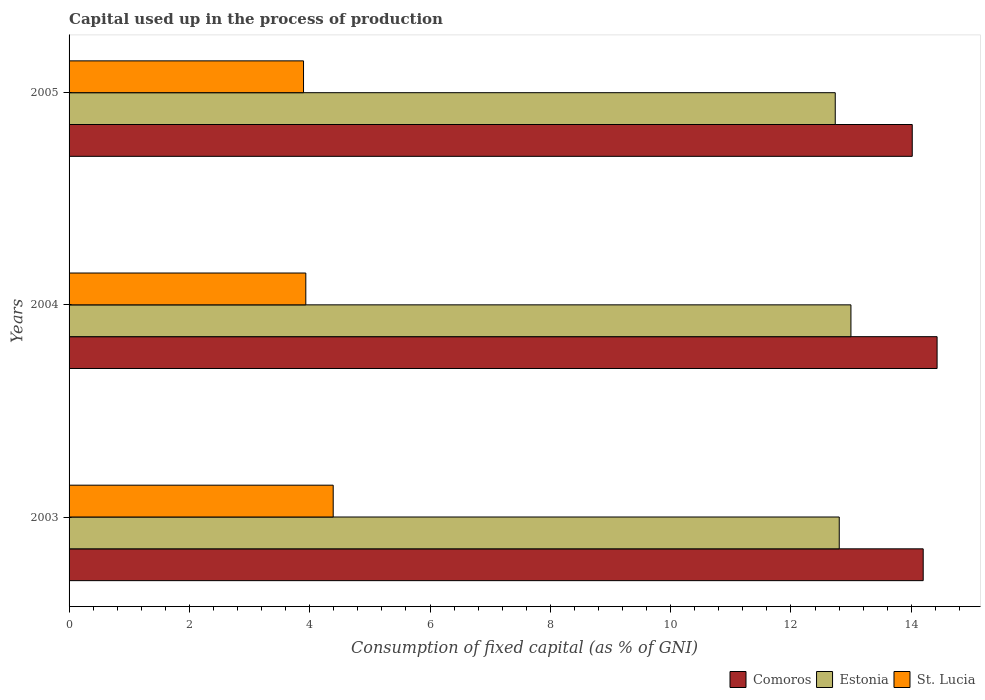How many different coloured bars are there?
Your answer should be compact. 3. What is the label of the 2nd group of bars from the top?
Offer a terse response. 2004. What is the capital used up in the process of production in Estonia in 2003?
Offer a terse response. 12.8. Across all years, what is the maximum capital used up in the process of production in St. Lucia?
Your response must be concise. 4.39. Across all years, what is the minimum capital used up in the process of production in Estonia?
Your answer should be compact. 12.74. In which year was the capital used up in the process of production in Comoros maximum?
Keep it short and to the point. 2004. What is the total capital used up in the process of production in Estonia in the graph?
Make the answer very short. 38.54. What is the difference between the capital used up in the process of production in Comoros in 2003 and that in 2005?
Your answer should be very brief. 0.18. What is the difference between the capital used up in the process of production in Comoros in 2004 and the capital used up in the process of production in Estonia in 2003?
Your answer should be compact. 1.63. What is the average capital used up in the process of production in Estonia per year?
Make the answer very short. 12.85. In the year 2005, what is the difference between the capital used up in the process of production in Estonia and capital used up in the process of production in St. Lucia?
Ensure brevity in your answer.  8.84. In how many years, is the capital used up in the process of production in St. Lucia greater than 6 %?
Your response must be concise. 0. What is the ratio of the capital used up in the process of production in Estonia in 2003 to that in 2004?
Provide a succinct answer. 0.99. What is the difference between the highest and the second highest capital used up in the process of production in Estonia?
Provide a succinct answer. 0.19. What is the difference between the highest and the lowest capital used up in the process of production in Estonia?
Keep it short and to the point. 0.26. In how many years, is the capital used up in the process of production in Estonia greater than the average capital used up in the process of production in Estonia taken over all years?
Make the answer very short. 1. Is the sum of the capital used up in the process of production in Estonia in 2004 and 2005 greater than the maximum capital used up in the process of production in St. Lucia across all years?
Keep it short and to the point. Yes. What does the 2nd bar from the top in 2004 represents?
Make the answer very short. Estonia. What does the 1st bar from the bottom in 2004 represents?
Your response must be concise. Comoros. Is it the case that in every year, the sum of the capital used up in the process of production in Comoros and capital used up in the process of production in Estonia is greater than the capital used up in the process of production in St. Lucia?
Keep it short and to the point. Yes. What is the difference between two consecutive major ticks on the X-axis?
Give a very brief answer. 2. Are the values on the major ticks of X-axis written in scientific E-notation?
Your answer should be compact. No. Does the graph contain grids?
Provide a short and direct response. No. Where does the legend appear in the graph?
Provide a succinct answer. Bottom right. How are the legend labels stacked?
Give a very brief answer. Horizontal. What is the title of the graph?
Your answer should be very brief. Capital used up in the process of production. What is the label or title of the X-axis?
Give a very brief answer. Consumption of fixed capital (as % of GNI). What is the label or title of the Y-axis?
Your answer should be very brief. Years. What is the Consumption of fixed capital (as % of GNI) of Comoros in 2003?
Your answer should be compact. 14.2. What is the Consumption of fixed capital (as % of GNI) in Estonia in 2003?
Your response must be concise. 12.8. What is the Consumption of fixed capital (as % of GNI) in St. Lucia in 2003?
Your answer should be compact. 4.39. What is the Consumption of fixed capital (as % of GNI) of Comoros in 2004?
Provide a short and direct response. 14.43. What is the Consumption of fixed capital (as % of GNI) in Estonia in 2004?
Keep it short and to the point. 13. What is the Consumption of fixed capital (as % of GNI) of St. Lucia in 2004?
Your answer should be compact. 3.94. What is the Consumption of fixed capital (as % of GNI) in Comoros in 2005?
Ensure brevity in your answer.  14.02. What is the Consumption of fixed capital (as % of GNI) in Estonia in 2005?
Your answer should be very brief. 12.74. What is the Consumption of fixed capital (as % of GNI) of St. Lucia in 2005?
Your response must be concise. 3.9. Across all years, what is the maximum Consumption of fixed capital (as % of GNI) of Comoros?
Offer a very short reply. 14.43. Across all years, what is the maximum Consumption of fixed capital (as % of GNI) of Estonia?
Make the answer very short. 13. Across all years, what is the maximum Consumption of fixed capital (as % of GNI) of St. Lucia?
Provide a short and direct response. 4.39. Across all years, what is the minimum Consumption of fixed capital (as % of GNI) in Comoros?
Make the answer very short. 14.02. Across all years, what is the minimum Consumption of fixed capital (as % of GNI) in Estonia?
Your answer should be compact. 12.74. Across all years, what is the minimum Consumption of fixed capital (as % of GNI) of St. Lucia?
Make the answer very short. 3.9. What is the total Consumption of fixed capital (as % of GNI) of Comoros in the graph?
Offer a terse response. 42.64. What is the total Consumption of fixed capital (as % of GNI) in Estonia in the graph?
Offer a terse response. 38.54. What is the total Consumption of fixed capital (as % of GNI) of St. Lucia in the graph?
Offer a terse response. 12.22. What is the difference between the Consumption of fixed capital (as % of GNI) in Comoros in 2003 and that in 2004?
Make the answer very short. -0.23. What is the difference between the Consumption of fixed capital (as % of GNI) of Estonia in 2003 and that in 2004?
Provide a succinct answer. -0.19. What is the difference between the Consumption of fixed capital (as % of GNI) in St. Lucia in 2003 and that in 2004?
Your response must be concise. 0.46. What is the difference between the Consumption of fixed capital (as % of GNI) of Comoros in 2003 and that in 2005?
Your answer should be very brief. 0.18. What is the difference between the Consumption of fixed capital (as % of GNI) in Estonia in 2003 and that in 2005?
Ensure brevity in your answer.  0.07. What is the difference between the Consumption of fixed capital (as % of GNI) of St. Lucia in 2003 and that in 2005?
Give a very brief answer. 0.49. What is the difference between the Consumption of fixed capital (as % of GNI) in Comoros in 2004 and that in 2005?
Give a very brief answer. 0.41. What is the difference between the Consumption of fixed capital (as % of GNI) in Estonia in 2004 and that in 2005?
Ensure brevity in your answer.  0.26. What is the difference between the Consumption of fixed capital (as % of GNI) in St. Lucia in 2004 and that in 2005?
Provide a succinct answer. 0.04. What is the difference between the Consumption of fixed capital (as % of GNI) in Comoros in 2003 and the Consumption of fixed capital (as % of GNI) in Estonia in 2004?
Keep it short and to the point. 1.2. What is the difference between the Consumption of fixed capital (as % of GNI) in Comoros in 2003 and the Consumption of fixed capital (as % of GNI) in St. Lucia in 2004?
Make the answer very short. 10.26. What is the difference between the Consumption of fixed capital (as % of GNI) of Estonia in 2003 and the Consumption of fixed capital (as % of GNI) of St. Lucia in 2004?
Keep it short and to the point. 8.87. What is the difference between the Consumption of fixed capital (as % of GNI) of Comoros in 2003 and the Consumption of fixed capital (as % of GNI) of Estonia in 2005?
Provide a short and direct response. 1.46. What is the difference between the Consumption of fixed capital (as % of GNI) in Comoros in 2003 and the Consumption of fixed capital (as % of GNI) in St. Lucia in 2005?
Your answer should be compact. 10.3. What is the difference between the Consumption of fixed capital (as % of GNI) of Estonia in 2003 and the Consumption of fixed capital (as % of GNI) of St. Lucia in 2005?
Keep it short and to the point. 8.91. What is the difference between the Consumption of fixed capital (as % of GNI) in Comoros in 2004 and the Consumption of fixed capital (as % of GNI) in Estonia in 2005?
Provide a short and direct response. 1.69. What is the difference between the Consumption of fixed capital (as % of GNI) in Comoros in 2004 and the Consumption of fixed capital (as % of GNI) in St. Lucia in 2005?
Ensure brevity in your answer.  10.53. What is the difference between the Consumption of fixed capital (as % of GNI) of Estonia in 2004 and the Consumption of fixed capital (as % of GNI) of St. Lucia in 2005?
Your answer should be very brief. 9.1. What is the average Consumption of fixed capital (as % of GNI) of Comoros per year?
Make the answer very short. 14.21. What is the average Consumption of fixed capital (as % of GNI) of Estonia per year?
Your response must be concise. 12.85. What is the average Consumption of fixed capital (as % of GNI) of St. Lucia per year?
Your response must be concise. 4.07. In the year 2003, what is the difference between the Consumption of fixed capital (as % of GNI) of Comoros and Consumption of fixed capital (as % of GNI) of Estonia?
Keep it short and to the point. 1.4. In the year 2003, what is the difference between the Consumption of fixed capital (as % of GNI) in Comoros and Consumption of fixed capital (as % of GNI) in St. Lucia?
Give a very brief answer. 9.81. In the year 2003, what is the difference between the Consumption of fixed capital (as % of GNI) in Estonia and Consumption of fixed capital (as % of GNI) in St. Lucia?
Your answer should be very brief. 8.41. In the year 2004, what is the difference between the Consumption of fixed capital (as % of GNI) of Comoros and Consumption of fixed capital (as % of GNI) of Estonia?
Ensure brevity in your answer.  1.43. In the year 2004, what is the difference between the Consumption of fixed capital (as % of GNI) of Comoros and Consumption of fixed capital (as % of GNI) of St. Lucia?
Make the answer very short. 10.49. In the year 2004, what is the difference between the Consumption of fixed capital (as % of GNI) in Estonia and Consumption of fixed capital (as % of GNI) in St. Lucia?
Make the answer very short. 9.06. In the year 2005, what is the difference between the Consumption of fixed capital (as % of GNI) of Comoros and Consumption of fixed capital (as % of GNI) of Estonia?
Offer a very short reply. 1.28. In the year 2005, what is the difference between the Consumption of fixed capital (as % of GNI) in Comoros and Consumption of fixed capital (as % of GNI) in St. Lucia?
Ensure brevity in your answer.  10.12. In the year 2005, what is the difference between the Consumption of fixed capital (as % of GNI) in Estonia and Consumption of fixed capital (as % of GNI) in St. Lucia?
Your answer should be compact. 8.84. What is the ratio of the Consumption of fixed capital (as % of GNI) of Estonia in 2003 to that in 2004?
Provide a succinct answer. 0.99. What is the ratio of the Consumption of fixed capital (as % of GNI) of St. Lucia in 2003 to that in 2004?
Your answer should be compact. 1.12. What is the ratio of the Consumption of fixed capital (as % of GNI) in St. Lucia in 2003 to that in 2005?
Your answer should be compact. 1.13. What is the ratio of the Consumption of fixed capital (as % of GNI) in Comoros in 2004 to that in 2005?
Your answer should be very brief. 1.03. What is the ratio of the Consumption of fixed capital (as % of GNI) of Estonia in 2004 to that in 2005?
Offer a terse response. 1.02. What is the ratio of the Consumption of fixed capital (as % of GNI) of St. Lucia in 2004 to that in 2005?
Offer a very short reply. 1.01. What is the difference between the highest and the second highest Consumption of fixed capital (as % of GNI) of Comoros?
Your response must be concise. 0.23. What is the difference between the highest and the second highest Consumption of fixed capital (as % of GNI) of Estonia?
Offer a very short reply. 0.19. What is the difference between the highest and the second highest Consumption of fixed capital (as % of GNI) of St. Lucia?
Provide a short and direct response. 0.46. What is the difference between the highest and the lowest Consumption of fixed capital (as % of GNI) of Comoros?
Provide a succinct answer. 0.41. What is the difference between the highest and the lowest Consumption of fixed capital (as % of GNI) of Estonia?
Your answer should be very brief. 0.26. What is the difference between the highest and the lowest Consumption of fixed capital (as % of GNI) of St. Lucia?
Provide a succinct answer. 0.49. 